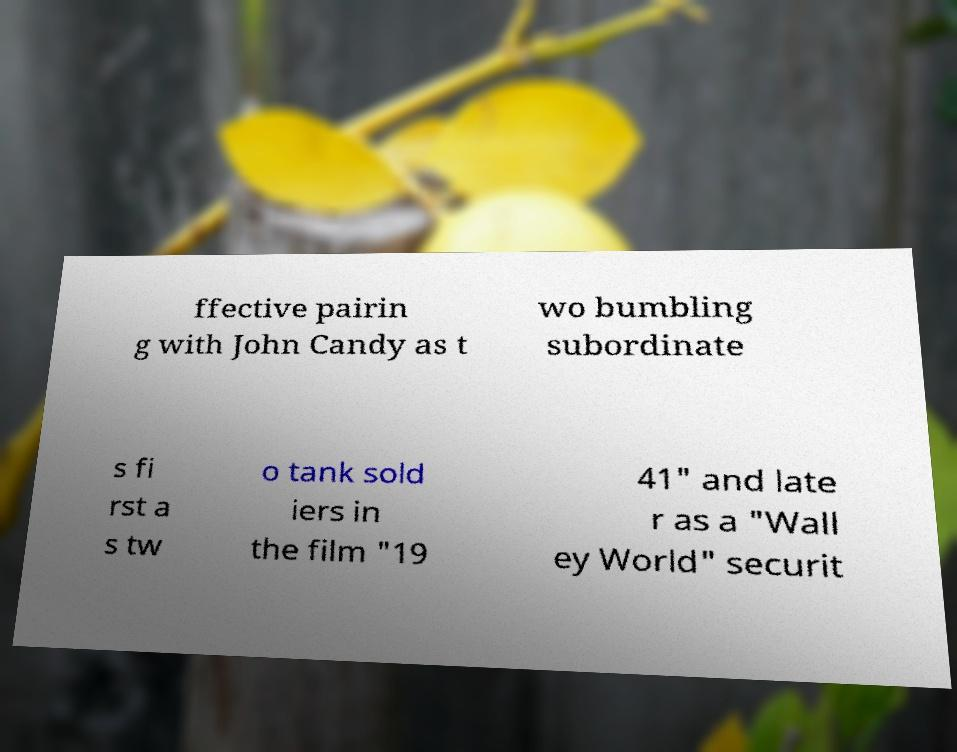Can you accurately transcribe the text from the provided image for me? ffective pairin g with John Candy as t wo bumbling subordinate s fi rst a s tw o tank sold iers in the film "19 41" and late r as a "Wall ey World" securit 